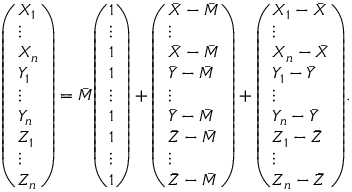Convert formula to latex. <formula><loc_0><loc_0><loc_500><loc_500>{ \left ( \begin{array} { l } { X _ { 1 } } \\ { \vdots } \\ { X _ { n } } \\ { Y _ { 1 } } \\ { \vdots } \\ { Y _ { n } } \\ { Z _ { 1 } } \\ { \vdots } \\ { Z _ { n } } \end{array} \right ) } = { \bar { M } } { \left ( \begin{array} { l } { 1 } \\ { \vdots } \\ { 1 } \\ { 1 } \\ { \vdots } \\ { 1 } \\ { 1 } \\ { \vdots } \\ { 1 } \end{array} \right ) } + { \left ( \begin{array} { l } { { \bar { X } } - { \bar { M } } } \\ { \vdots } \\ { { \bar { X } } - { \bar { M } } } \\ { { \bar { Y } } - { \bar { M } } } \\ { \vdots } \\ { { \bar { Y } } - { \bar { M } } } \\ { { \bar { Z } } - { \bar { M } } } \\ { \vdots } \\ { { \bar { Z } } - { \bar { M } } } \end{array} \right ) } + { \left ( \begin{array} { l } { X _ { 1 } - { \bar { X } } } \\ { \vdots } \\ { X _ { n } - { \bar { X } } } \\ { Y _ { 1 } - { \bar { Y } } } \\ { \vdots } \\ { Y _ { n } - { \bar { Y } } } \\ { Z _ { 1 } - { \bar { Z } } } \\ { \vdots } \\ { Z _ { n } - { \bar { Z } } } \end{array} \right ) } .</formula> 